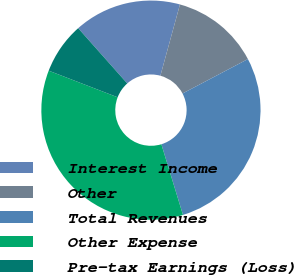<chart> <loc_0><loc_0><loc_500><loc_500><pie_chart><fcel>Interest Income<fcel>Other<fcel>Total Revenues<fcel>Other Expense<fcel>Pre-tax Earnings (Loss)<nl><fcel>15.82%<fcel>13.02%<fcel>27.99%<fcel>35.58%<fcel>7.58%<nl></chart> 